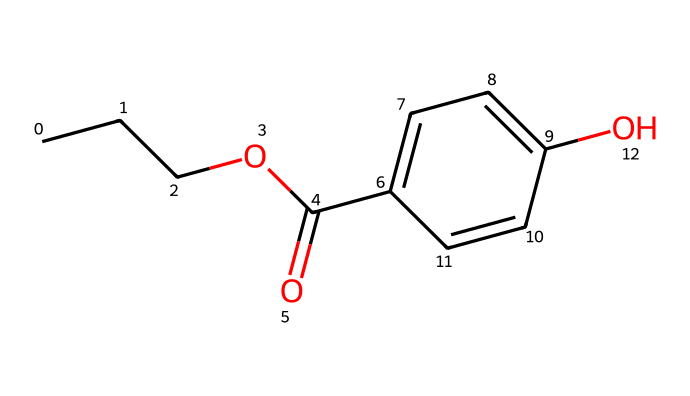What is the molecular formula of propylparaben? The SMILES structure indicates that propylparaben contains carbon (C), hydrogen (H), and oxygen (O) atoms. By interpreting the SMILES, we identify 10 carbon atoms, 12 hydrogen atoms, and 4 oxygen atoms, leading to a molecular formula of C10H12O4.
Answer: C10H12O4 How many carbon atoms are present in propylparaben? From the SMILES representation, each "C" in the structure represents a carbon atom. Counting the number of "C" symbols in the provided structure gives a total of 10 carbon atoms.
Answer: 10 What functional groups are present in propylparaben? The SMILES notation reveals both an ester group (C(=O)O) associated with the propyl side and a hydroxyl group (–OH). Recognizing these functional groups allows us to identify the presence of an ester and an alcohol in propylparaben.
Answer: ester and alcohol Is propylparaben more likely to be soluble in water or in oils? Analyzing the structure of propylparaben, the presence of the hydroxyl group suggests potential hydrogen bonding with water; however, the large hydrocarbon tail (C3H7) makes it less polar. Conclusively, the overall characteristics imply that propylparaben would have greater solubility in oils due to its nonpolar components.
Answer: oils What is the position of the hydroxyl group in the benzene ring of propylparaben? By examining the part of the SMILES notation corresponding to the aromatic ring (C1=CC=C(C=C1)), we can locate the position of the hydroxyl group as being directly attached to the carbon at position 4 of the ring (counting the position attached to the carbonyl as 1).
Answer: position 4 How does propylparaben function as a preservative? Propylparaben acts as a preservative by inhibiting the growth of microorganisms, specifically bacteria and fungi, owing to its ability to disrupt cellular processes. The benzene ring’s structure allows it to interact with microbial cells and prevent replication, thus extending shelf life.
Answer: inhibits microbial growth 